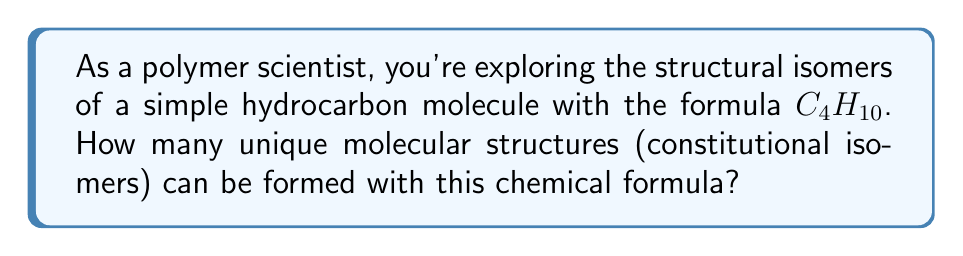Could you help me with this problem? To solve this problem, let's approach it step-by-step:

1) First, we need to understand what $C_4H_{10}$ represents:
   - 4 carbon atoms
   - 10 hydrogen atoms

2) The possible structures are limited by the valence of carbon (4) and hydrogen (1).

3) Let's consider the possible carbon skeletons:
   a) Straight chain: $C-C-C-C$
   b) Branched chain: $C-C-C$
                       |
                       $C$

4) For the straight chain (n-butane):
   $$CH_3-CH_2-CH_2-CH_3$$
   This is one unique structure.

5) For the branched chain (isobutane):
   $$CH_3-CH(CH_3)-CH_3$$
   This is another unique structure.

6) There are no other ways to arrange 4 carbon atoms while maintaining their valence.

7) Each of these structures satisfies the formula $C_4H_{10}$, as each carbon atom is bonded to 4 other atoms (either C or H), and all remaining bonds are filled by hydrogen atoms.

8) Therefore, the total number of unique molecular structures (constitutional isomers) for $C_4H_{10}$ is 2.

This problem demonstrates the importance of understanding molecular structure in polymer science, as the arrangement of atoms can significantly affect a molecule's properties.
Answer: 2 